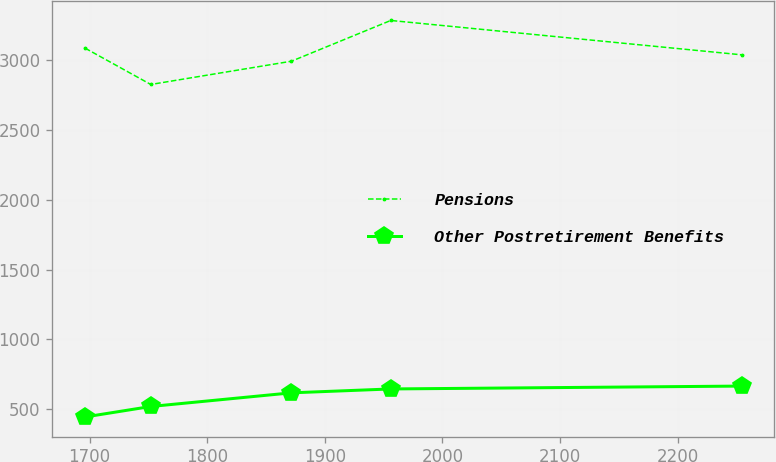<chart> <loc_0><loc_0><loc_500><loc_500><line_chart><ecel><fcel>Pensions<fcel>Other Postretirement Benefits<nl><fcel>1696.18<fcel>3087.59<fcel>443.91<nl><fcel>1752<fcel>2827.25<fcel>518.98<nl><fcel>1871.61<fcel>2994.02<fcel>616.84<nl><fcel>1956.06<fcel>3286.18<fcel>644.66<nl><fcel>2254.38<fcel>3039.91<fcel>665.25<nl></chart> 